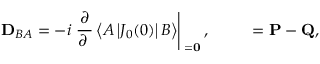<formula> <loc_0><loc_0><loc_500><loc_500>{ { D } _ { B A } } = - i \frac { \partial } { \partial { \Delta } } \left < A \left | { J _ { 0 } } ( 0 ) \right | B \right > \right | _ { \Delta = 0 } , \quad { \Delta } = { P } - { Q } ,</formula> 